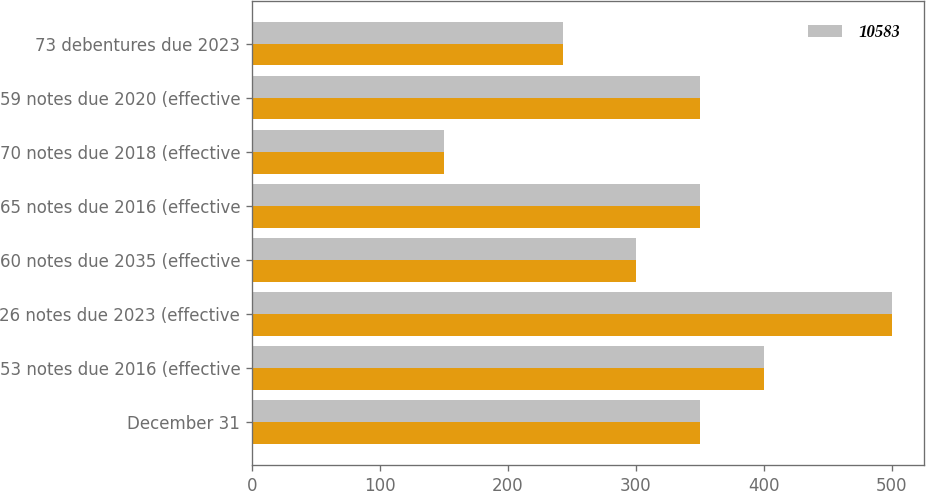Convert chart. <chart><loc_0><loc_0><loc_500><loc_500><stacked_bar_chart><ecel><fcel>December 31<fcel>53 notes due 2016 (effective<fcel>26 notes due 2023 (effective<fcel>60 notes due 2035 (effective<fcel>65 notes due 2016 (effective<fcel>70 notes due 2018 (effective<fcel>59 notes due 2020 (effective<fcel>73 debentures due 2023<nl><fcel>nan<fcel>350<fcel>400<fcel>500<fcel>300<fcel>350<fcel>150<fcel>350<fcel>243<nl><fcel>10583<fcel>350<fcel>400<fcel>500<fcel>300<fcel>350<fcel>150<fcel>350<fcel>243<nl></chart> 